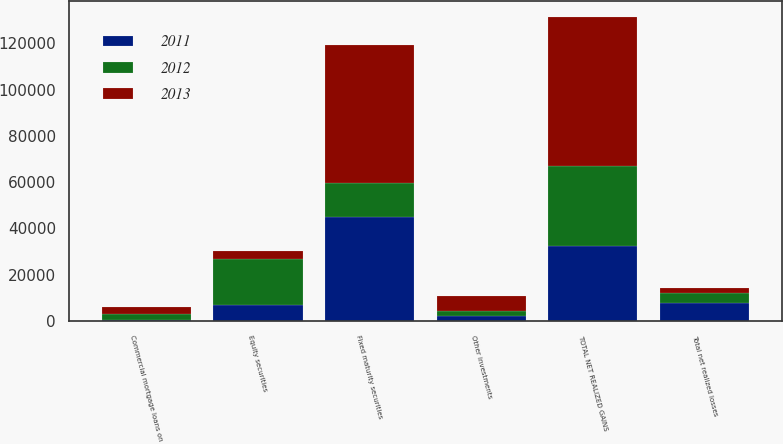<chart> <loc_0><loc_0><loc_500><loc_500><stacked_bar_chart><ecel><fcel>Fixed maturity securities<fcel>Equity securities<fcel>Commercial mortgage loans on<fcel>Other investments<fcel>TOTAL NET REALIZED GAINS<fcel>Total net realized losses<nl><fcel>2012<fcel>14579<fcel>19789<fcel>2515<fcel>2029<fcel>34525<fcel>4387<nl><fcel>2013<fcel>59815<fcel>3466<fcel>3072<fcel>6775<fcel>64353<fcel>1843<nl><fcel>2011<fcel>44924<fcel>7010<fcel>336<fcel>2166<fcel>32580<fcel>7836<nl></chart> 